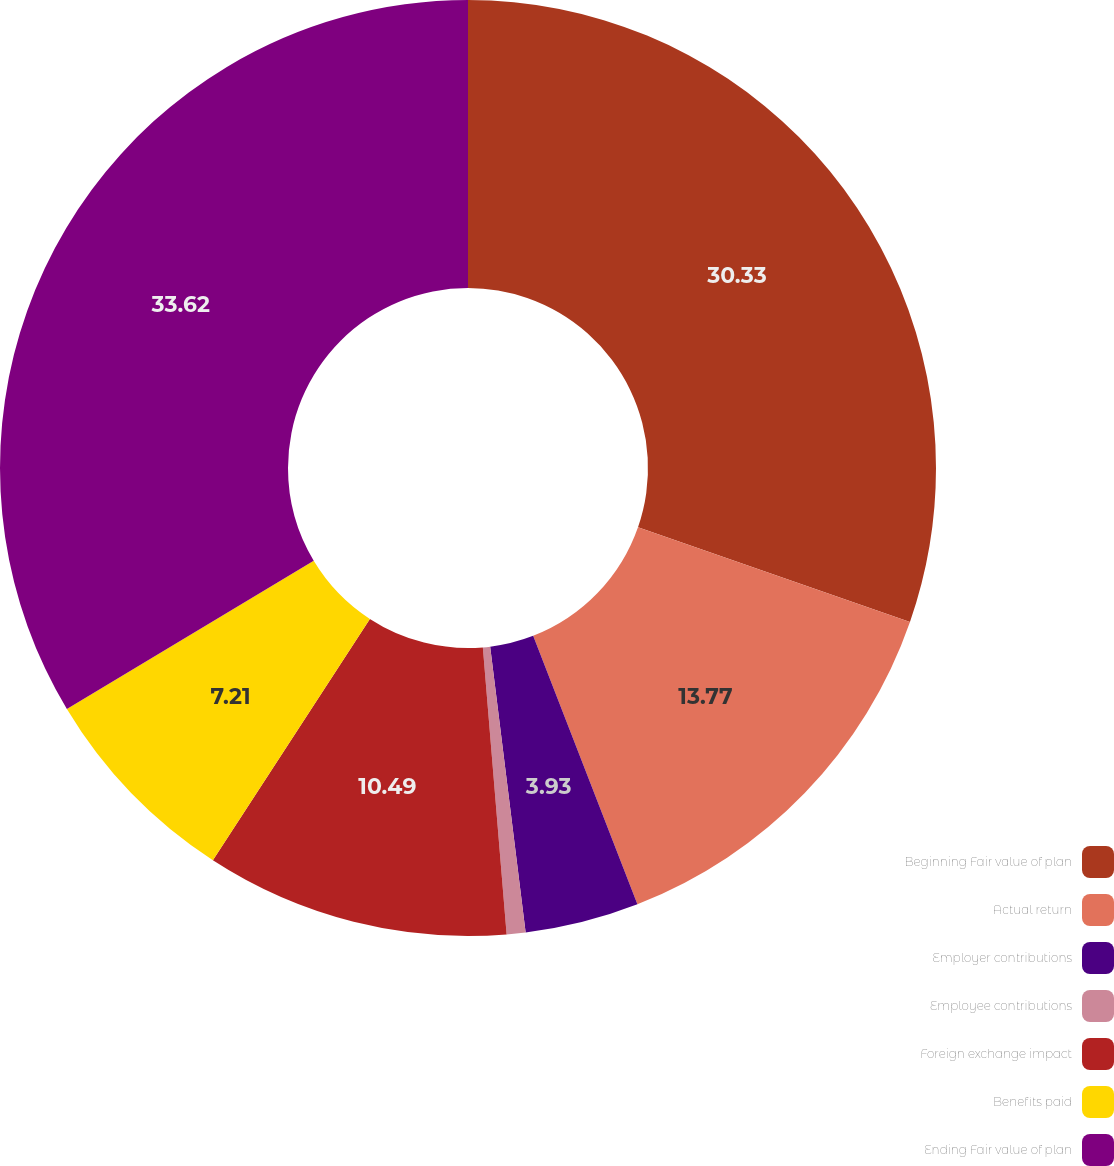Convert chart to OTSL. <chart><loc_0><loc_0><loc_500><loc_500><pie_chart><fcel>Beginning Fair value of plan<fcel>Actual return<fcel>Employer contributions<fcel>Employee contributions<fcel>Foreign exchange impact<fcel>Benefits paid<fcel>Ending Fair value of plan<nl><fcel>30.33%<fcel>13.77%<fcel>3.93%<fcel>0.65%<fcel>10.49%<fcel>7.21%<fcel>33.61%<nl></chart> 